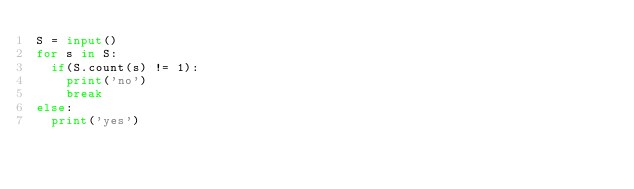<code> <loc_0><loc_0><loc_500><loc_500><_Python_>S = input()
for s in S:
  if(S.count(s) != 1):
    print('no')
    break
else:
  print('yes')</code> 